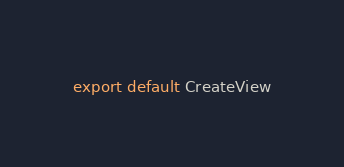<code> <loc_0><loc_0><loc_500><loc_500><_JavaScript_>export default CreateView
</code> 